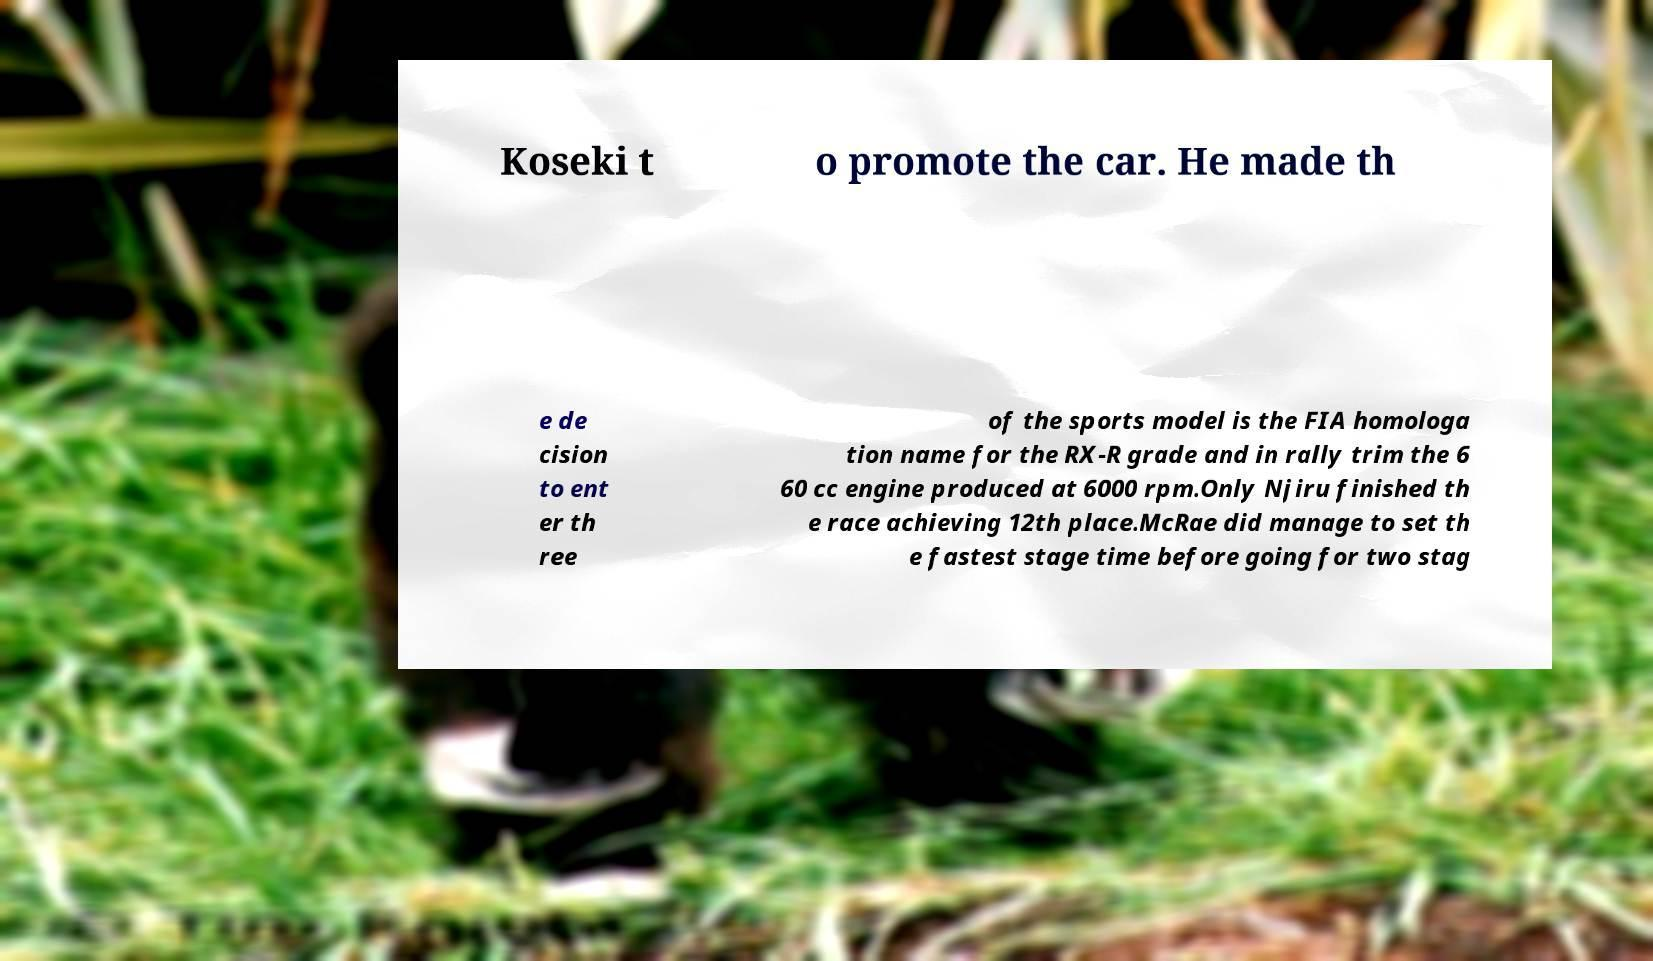For documentation purposes, I need the text within this image transcribed. Could you provide that? Koseki t o promote the car. He made th e de cision to ent er th ree of the sports model is the FIA homologa tion name for the RX-R grade and in rally trim the 6 60 cc engine produced at 6000 rpm.Only Njiru finished th e race achieving 12th place.McRae did manage to set th e fastest stage time before going for two stag 